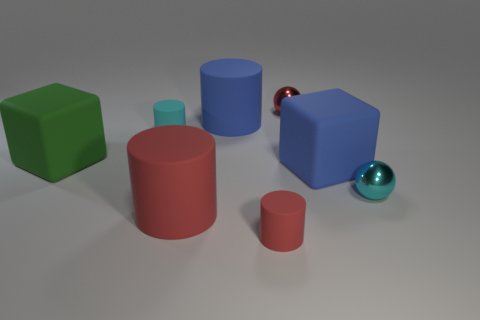Add 2 large green rubber cylinders. How many objects exist? 10 Subtract all balls. How many objects are left? 6 Add 3 small cyan metal things. How many small cyan metal things are left? 4 Add 5 large red things. How many large red things exist? 6 Subtract 0 brown cylinders. How many objects are left? 8 Subtract all small yellow things. Subtract all red objects. How many objects are left? 5 